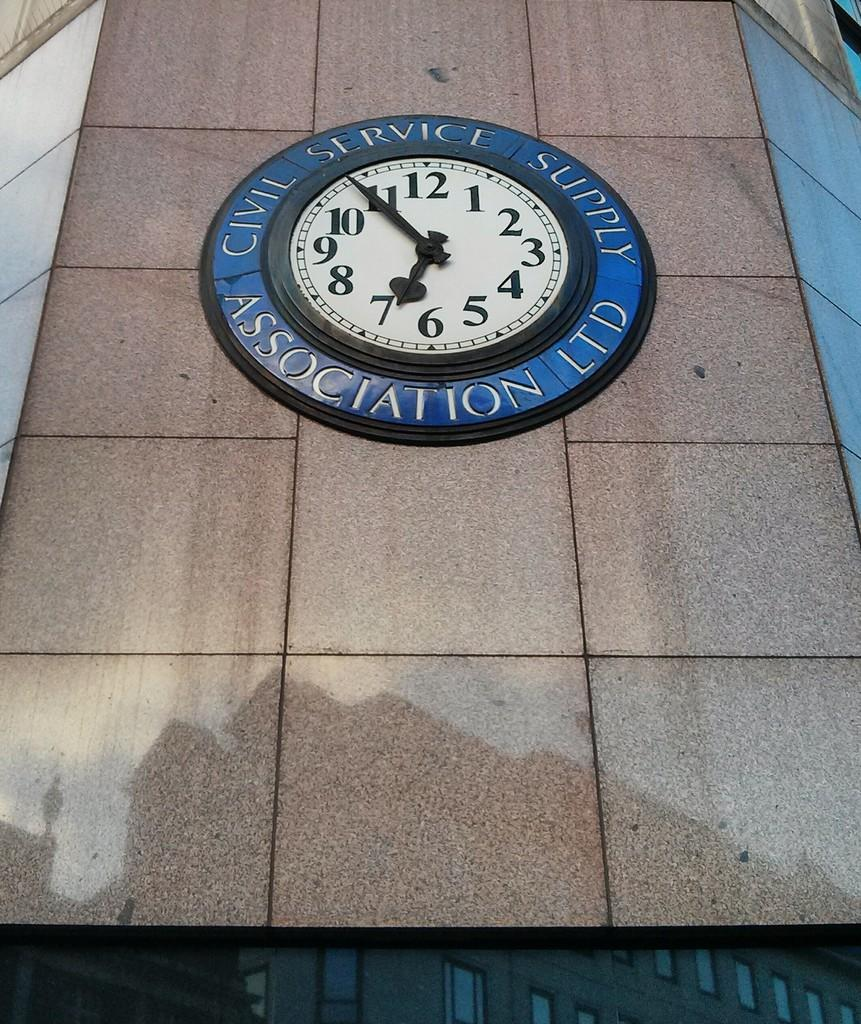Provide a one-sentence caption for the provided image. A clock on a building's wall that reads civil service supply association LTD. 